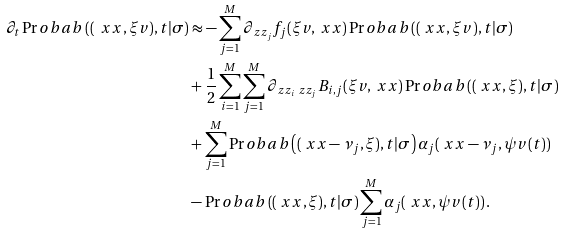<formula> <loc_0><loc_0><loc_500><loc_500>\partial _ { t } \Pr o b a b \left ( ( \ x x , \xi v ) , t | \sigma \right ) & \approx - \sum _ { j = 1 } ^ { M } \partial _ { \ z z _ { j } } f _ { j } ( \xi v , \ x x ) \Pr o b a b \left ( ( \ x x , \xi v ) , t | \sigma \right ) \\ & + \frac { 1 } { 2 } \sum _ { i = 1 } ^ { M } \sum _ { j = 1 } ^ { M } \partial _ { \ z z _ { i } \ z z _ { j } } B _ { i , j } ( \xi v , \ x x ) \Pr o b a b \left ( ( \ x x , \xi ) , t | \sigma \right ) \\ & + \sum _ { j = 1 } ^ { M } \Pr o b a b \left ( ( \ x x - \nu _ { j } , \xi ) , t | \sigma \right ) \alpha _ { j } ( \ x x - \nu _ { j } , \psi v ( t ) ) \\ & - \Pr o b a b \left ( ( \ x x , \xi ) , t | \sigma \right ) \sum _ { j = 1 } ^ { M } \alpha _ { j } ( \ x x , \psi v ( t ) ) \, .</formula> 